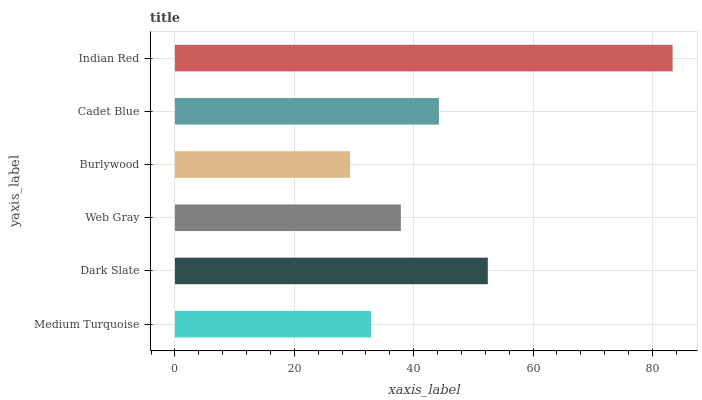Is Burlywood the minimum?
Answer yes or no. Yes. Is Indian Red the maximum?
Answer yes or no. Yes. Is Dark Slate the minimum?
Answer yes or no. No. Is Dark Slate the maximum?
Answer yes or no. No. Is Dark Slate greater than Medium Turquoise?
Answer yes or no. Yes. Is Medium Turquoise less than Dark Slate?
Answer yes or no. Yes. Is Medium Turquoise greater than Dark Slate?
Answer yes or no. No. Is Dark Slate less than Medium Turquoise?
Answer yes or no. No. Is Cadet Blue the high median?
Answer yes or no. Yes. Is Web Gray the low median?
Answer yes or no. Yes. Is Web Gray the high median?
Answer yes or no. No. Is Medium Turquoise the low median?
Answer yes or no. No. 